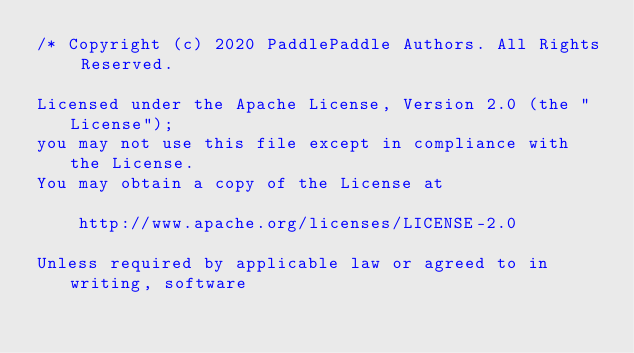Convert code to text. <code><loc_0><loc_0><loc_500><loc_500><_C++_>/* Copyright (c) 2020 PaddlePaddle Authors. All Rights Reserved.

Licensed under the Apache License, Version 2.0 (the "License");
you may not use this file except in compliance with the License.
You may obtain a copy of the License at

    http://www.apache.org/licenses/LICENSE-2.0

Unless required by applicable law or agreed to in writing, software</code> 